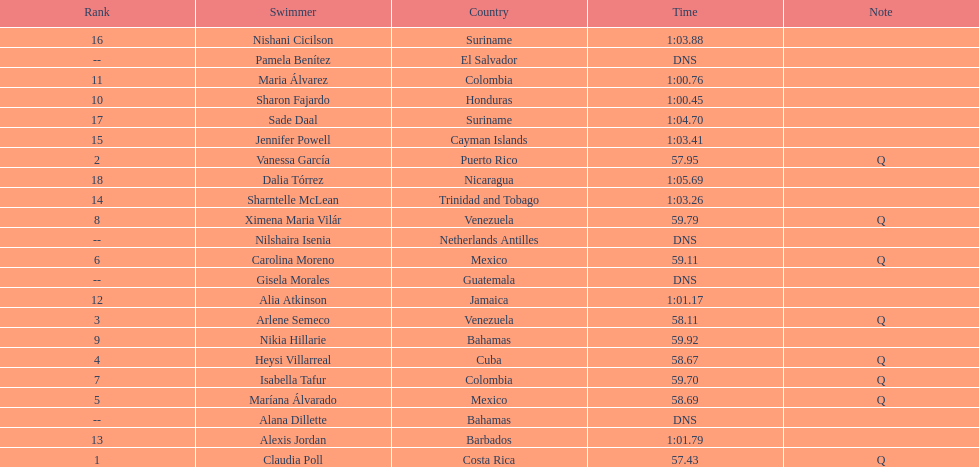How many mexican swimmers are there? 2. 